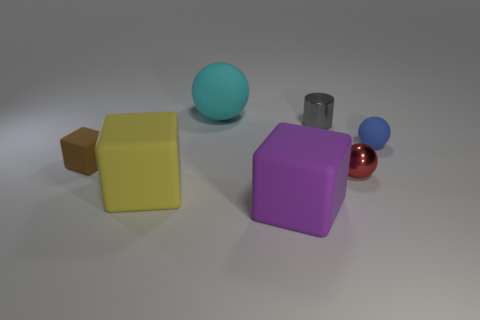Is the material of the big thing that is behind the gray metal thing the same as the red object that is right of the yellow rubber thing?
Give a very brief answer. No. There is a purple rubber object that is the same size as the cyan matte thing; what shape is it?
Ensure brevity in your answer.  Cube. Are there fewer big purple matte objects than blue matte cubes?
Your response must be concise. No. Are there any matte cubes on the right side of the large cube behind the purple rubber thing?
Make the answer very short. Yes. Is there a ball on the right side of the big rubber object behind the block left of the yellow object?
Ensure brevity in your answer.  Yes. Do the tiny shiny thing that is in front of the cylinder and the tiny matte thing that is on the right side of the big purple matte cube have the same shape?
Offer a terse response. Yes. There is another sphere that is the same material as the big sphere; what color is it?
Your response must be concise. Blue. Are there fewer tiny blue things on the right side of the big purple rubber object than big yellow things?
Provide a succinct answer. No. What size is the cube that is to the right of the ball that is left of the big matte object that is in front of the big yellow rubber object?
Keep it short and to the point. Large. Is the material of the tiny thing that is to the left of the tiny gray thing the same as the big ball?
Provide a succinct answer. Yes. 